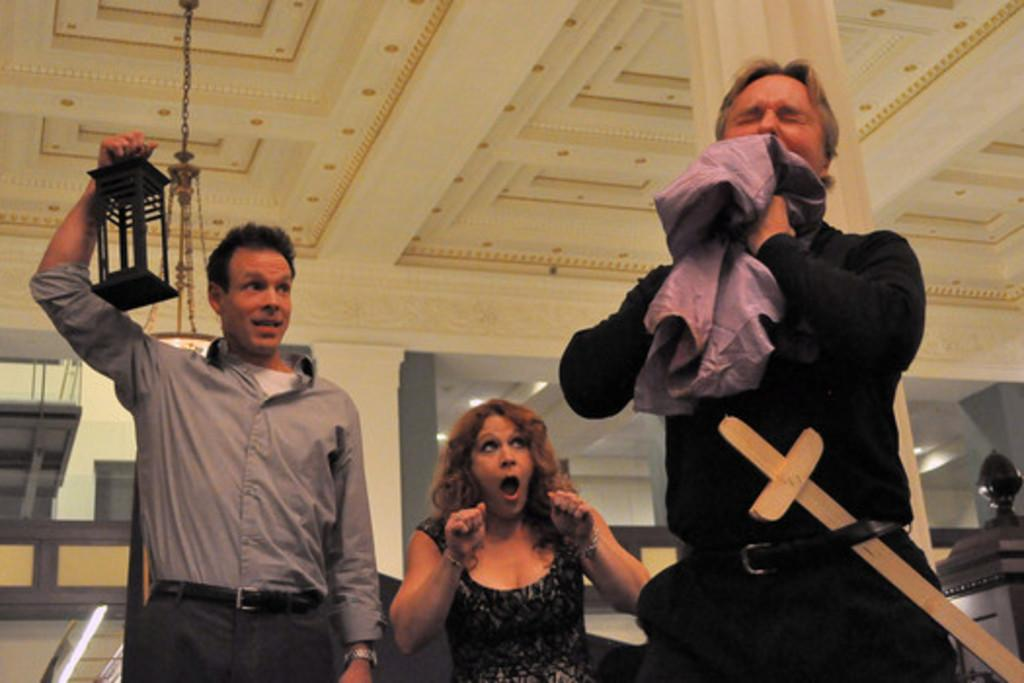What is the position of the man on the left side of the image? The man is on the left side of the image. What is the man on the left side of the image holding? The man on the left side of the image is holding something. What is the position of the man on the right side of the image? The man is on the right side of the image. What is the position of the woman in the image? The woman is in the middle of the image. What can be seen hanging on the wall at the top of the image? There is a light hanging on the wall at the top of the image. What type of texture can be seen on the whip in the image? There is no whip present in the image, so it is not possible to determine the texture. 